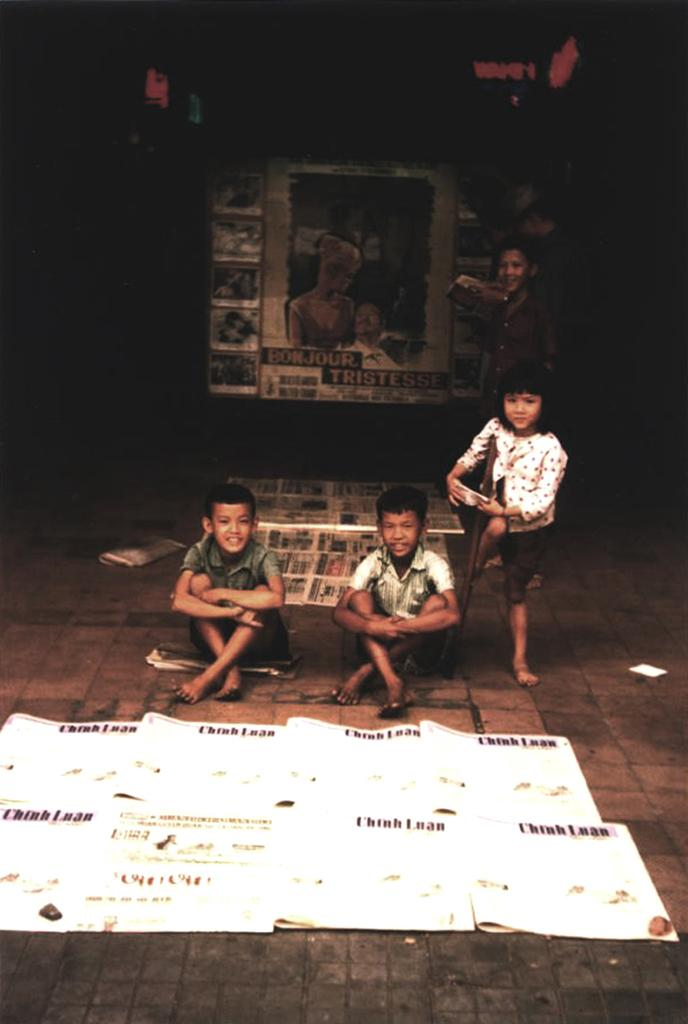What can be seen in the foreground of the image? There are children in the foreground of the image. What is located at the bottom side of the image? There are posters at the bottom side of the image. Can you describe the location of the posters in relation to the children? The posters may be in the background area of the image. How do the children pull the idea in the image? There is no mention of an idea or pulling in the image, so this question cannot be answered. 